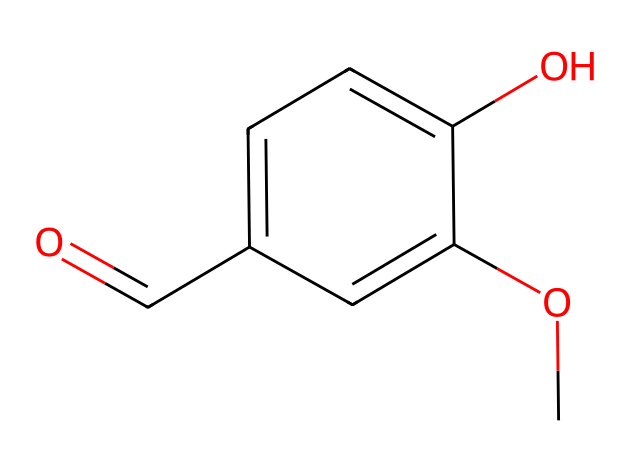What is the molecular formula of this chemical? To determine the molecular formula from the SMILES representation, we can decode the atoms present. The structure includes 9 carbon atoms (C), 10 hydrogen atoms (H), and 3 oxygen atoms (O). This gives us a molecular formula of C9H10O3.
Answer: C9H10O3 How many hydroxyl (–OH) groups are present in this chemical? By examining the SMILES representation, we can identify that there are two hydroxyl (–OH) groups indicated in the structure. Each "O" attached to a carbon with hydrogen can be described as a hydroxyl group, confirming two –OH groups exist.
Answer: 2 What is the functional group that gives this chemical its sweet flavor? The presence of the carbonyl group (C=O), as indicated in the structure near the aromatic ring, is essential for the sweet flavor characteristic of vanillin. This can be determined by recognizing the aldehyde functional group which is a significant contributor to the flavor profile.
Answer: aldehyde What type of compound is this chemical classified as? Analyzing the structure, this chemical includes aromatic rings and functional groups, making it aromatic. Additionally, it is known as a flavor compound, specifically a phenolic compound, contributing to its classification.
Answer: phenolic compound How many double bonds are present in this chemical? In the given SMILES representation, there is one double bond represented by "C=O" in the carbonyl group and typically another double bond in the aromatic ring, bringing the total to two. Thus, after examining the structure, we identify two double bonds total.
Answer: 2 Which aromatic feature can you identify in this chemical? The presence of a benzene-like ring structure is visible in the chemical representation, which demonstrates the characteristics of an aromatic compound. The alternating single and double bonds around the six-membered ring indicate the aromatic nature.
Answer: benzene ring 